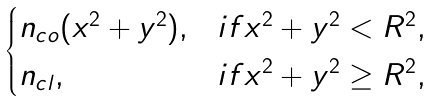<formula> <loc_0><loc_0><loc_500><loc_500>\begin{cases} n _ { c o } ( x ^ { 2 } + y ^ { 2 } ) , & i f x ^ { 2 } + y ^ { 2 } < R ^ { 2 } , \\ n _ { c l } , & i f x ^ { 2 } + y ^ { 2 } \geq R ^ { 2 } , \end{cases}</formula> 